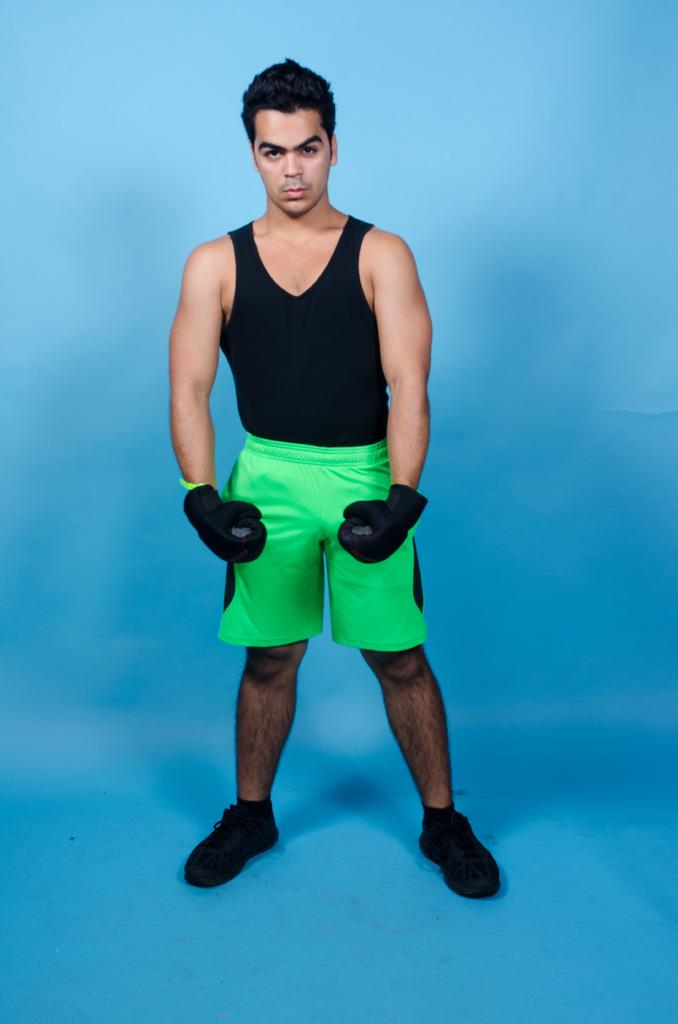What is the main subject of the image? The main subject of the image is a man. What type of clothing is the man wearing on his upper body? The man is wearing a t-shirt. What type of clothing is the man wearing on his lower body? The man is wearing shorts. What type of footwear is the man wearing? The man is wearing shoes. What is the man doing in the image? The man is standing and posing for the picture. What color is the background of the image? The background of the image is blue. What type of watch is the man wearing in the image? There is no watch visible in the image. What is the man doing with the hammer in the image? There is no hammer present in the image. What color is the gold object in the image? There is no gold object present in the image. 